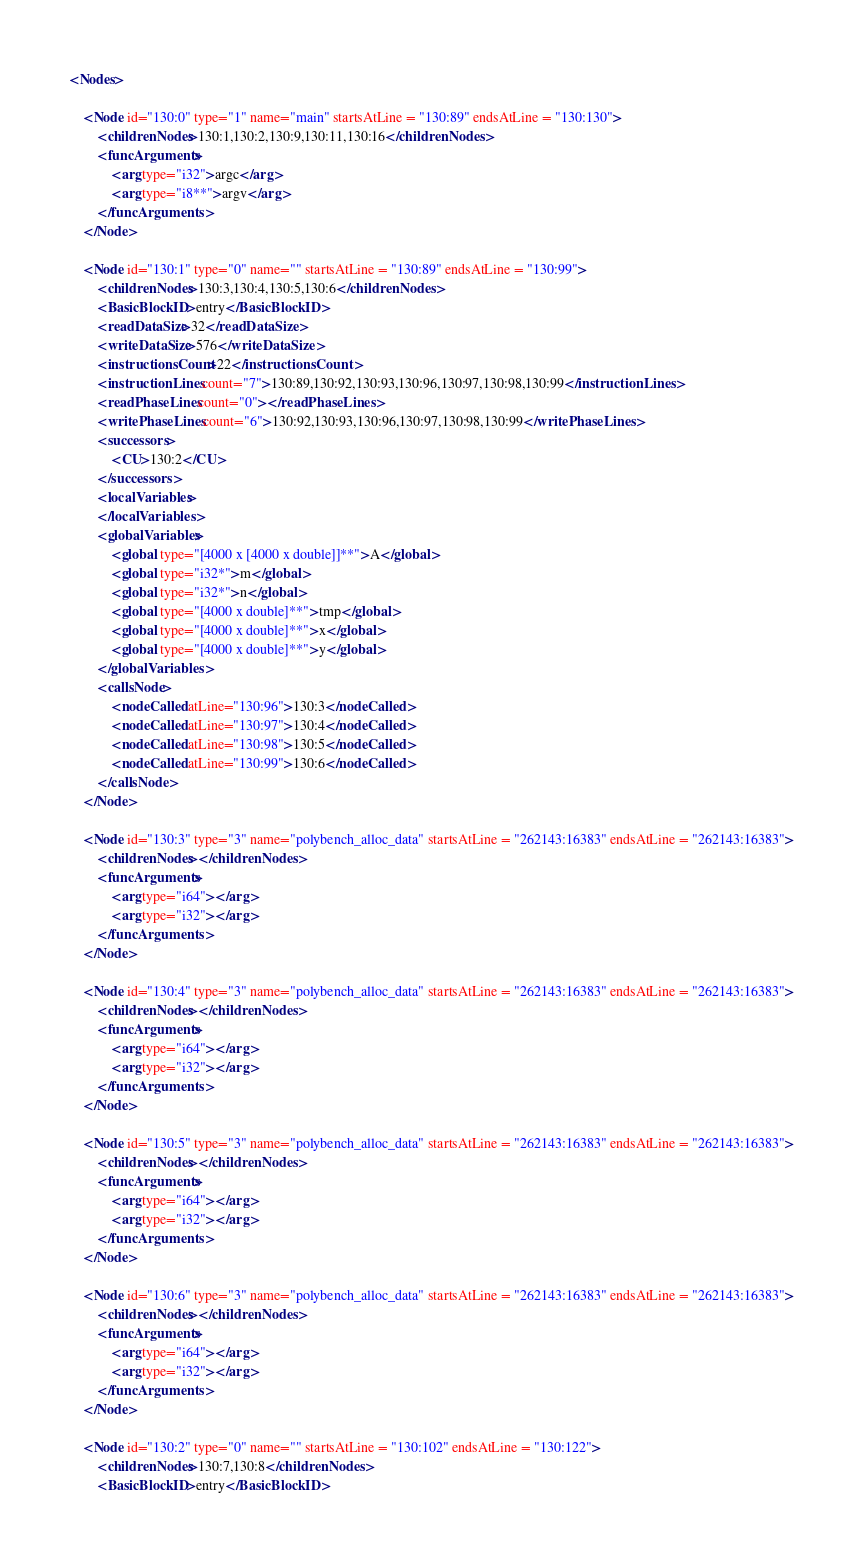<code> <loc_0><loc_0><loc_500><loc_500><_XML_><Nodes>

	<Node id="130:0" type="1" name="main" startsAtLine = "130:89" endsAtLine = "130:130">
		<childrenNodes>130:1,130:2,130:9,130:11,130:16</childrenNodes>
		<funcArguments>
			<arg type="i32">argc</arg>
			<arg type="i8**">argv</arg>
		</funcArguments>
	</Node>

	<Node id="130:1" type="0" name="" startsAtLine = "130:89" endsAtLine = "130:99">
		<childrenNodes>130:3,130:4,130:5,130:6</childrenNodes>
		<BasicBlockID>entry</BasicBlockID>
		<readDataSize>32</readDataSize>
		<writeDataSize>576</writeDataSize>
		<instructionsCount>22</instructionsCount>
		<instructionLines count="7">130:89,130:92,130:93,130:96,130:97,130:98,130:99</instructionLines>
		<readPhaseLines count="0"></readPhaseLines>
		<writePhaseLines count="6">130:92,130:93,130:96,130:97,130:98,130:99</writePhaseLines>
		<successors>
			<CU>130:2</CU>
		</successors>
		<localVariables>
		</localVariables>
		<globalVariables>
			<global type="[4000 x [4000 x double]]**">A</global>
			<global type="i32*">m</global>
			<global type="i32*">n</global>
			<global type="[4000 x double]**">tmp</global>
			<global type="[4000 x double]**">x</global>
			<global type="[4000 x double]**">y</global>
		</globalVariables>
		<callsNode>
			<nodeCalled atLine="130:96">130:3</nodeCalled>
			<nodeCalled atLine="130:97">130:4</nodeCalled>
			<nodeCalled atLine="130:98">130:5</nodeCalled>
			<nodeCalled atLine="130:99">130:6</nodeCalled>
		</callsNode>
	</Node>

	<Node id="130:3" type="3" name="polybench_alloc_data" startsAtLine = "262143:16383" endsAtLine = "262143:16383">
		<childrenNodes></childrenNodes>
		<funcArguments>
			<arg type="i64"></arg>
			<arg type="i32"></arg>
		</funcArguments>
	</Node>

	<Node id="130:4" type="3" name="polybench_alloc_data" startsAtLine = "262143:16383" endsAtLine = "262143:16383">
		<childrenNodes></childrenNodes>
		<funcArguments>
			<arg type="i64"></arg>
			<arg type="i32"></arg>
		</funcArguments>
	</Node>

	<Node id="130:5" type="3" name="polybench_alloc_data" startsAtLine = "262143:16383" endsAtLine = "262143:16383">
		<childrenNodes></childrenNodes>
		<funcArguments>
			<arg type="i64"></arg>
			<arg type="i32"></arg>
		</funcArguments>
	</Node>

	<Node id="130:6" type="3" name="polybench_alloc_data" startsAtLine = "262143:16383" endsAtLine = "262143:16383">
		<childrenNodes></childrenNodes>
		<funcArguments>
			<arg type="i64"></arg>
			<arg type="i32"></arg>
		</funcArguments>
	</Node>

	<Node id="130:2" type="0" name="" startsAtLine = "130:102" endsAtLine = "130:122">
		<childrenNodes>130:7,130:8</childrenNodes>
		<BasicBlockID>entry</BasicBlockID></code> 